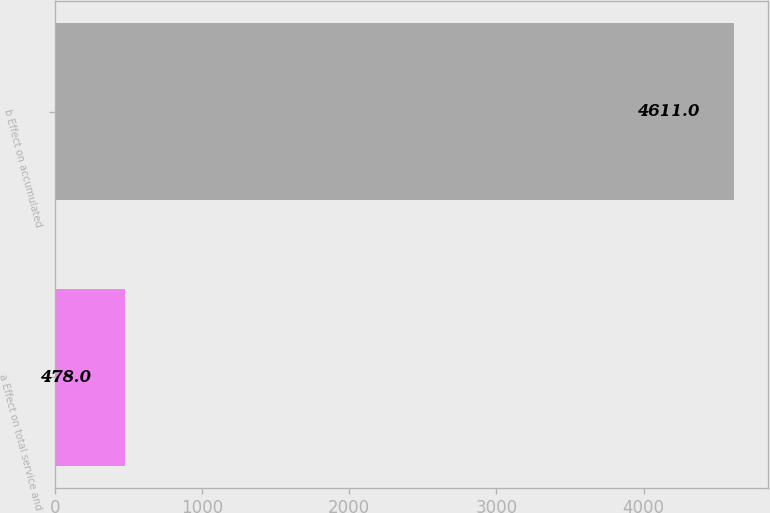<chart> <loc_0><loc_0><loc_500><loc_500><bar_chart><fcel>a Effect on total service and<fcel>b Effect on accumulated<nl><fcel>478<fcel>4611<nl></chart> 